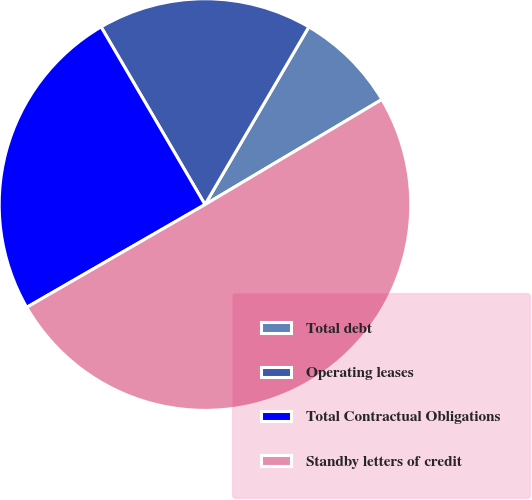Convert chart to OTSL. <chart><loc_0><loc_0><loc_500><loc_500><pie_chart><fcel>Total debt<fcel>Operating leases<fcel>Total Contractual Obligations<fcel>Standby letters of credit<nl><fcel>8.05%<fcel>16.84%<fcel>24.9%<fcel>50.21%<nl></chart> 